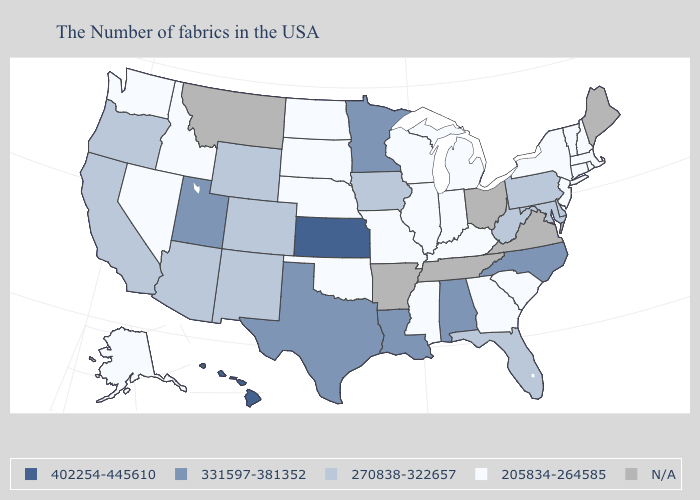Which states have the lowest value in the USA?
Concise answer only. Massachusetts, Rhode Island, New Hampshire, Vermont, Connecticut, New York, New Jersey, South Carolina, Georgia, Michigan, Kentucky, Indiana, Wisconsin, Illinois, Mississippi, Missouri, Nebraska, Oklahoma, South Dakota, North Dakota, Idaho, Nevada, Washington, Alaska. Name the states that have a value in the range N/A?
Quick response, please. Maine, Virginia, Ohio, Tennessee, Arkansas, Montana. What is the highest value in the USA?
Keep it brief. 402254-445610. Among the states that border Michigan , which have the highest value?
Give a very brief answer. Indiana, Wisconsin. How many symbols are there in the legend?
Be succinct. 5. Name the states that have a value in the range 205834-264585?
Write a very short answer. Massachusetts, Rhode Island, New Hampshire, Vermont, Connecticut, New York, New Jersey, South Carolina, Georgia, Michigan, Kentucky, Indiana, Wisconsin, Illinois, Mississippi, Missouri, Nebraska, Oklahoma, South Dakota, North Dakota, Idaho, Nevada, Washington, Alaska. How many symbols are there in the legend?
Give a very brief answer. 5. Name the states that have a value in the range 205834-264585?
Give a very brief answer. Massachusetts, Rhode Island, New Hampshire, Vermont, Connecticut, New York, New Jersey, South Carolina, Georgia, Michigan, Kentucky, Indiana, Wisconsin, Illinois, Mississippi, Missouri, Nebraska, Oklahoma, South Dakota, North Dakota, Idaho, Nevada, Washington, Alaska. What is the value of Alaska?
Keep it brief. 205834-264585. What is the lowest value in the USA?
Keep it brief. 205834-264585. Among the states that border Washington , does Idaho have the highest value?
Short answer required. No. 